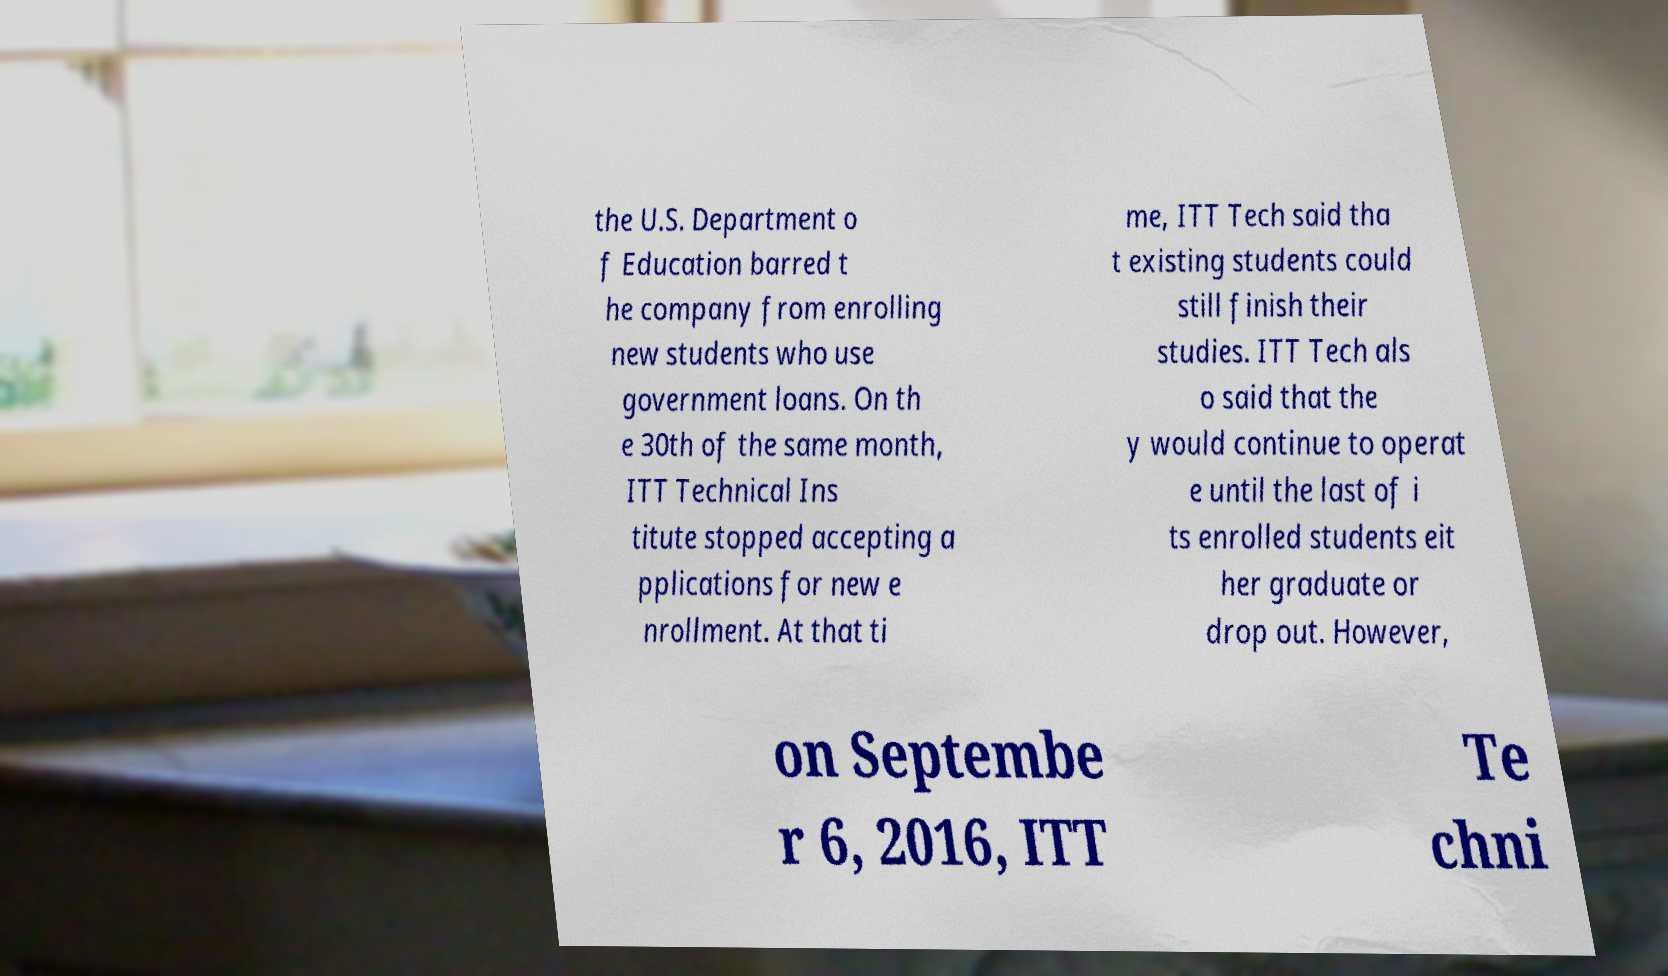Please read and relay the text visible in this image. What does it say? the U.S. Department o f Education barred t he company from enrolling new students who use government loans. On th e 30th of the same month, ITT Technical Ins titute stopped accepting a pplications for new e nrollment. At that ti me, ITT Tech said tha t existing students could still finish their studies. ITT Tech als o said that the y would continue to operat e until the last of i ts enrolled students eit her graduate or drop out. However, on Septembe r 6, 2016, ITT Te chni 